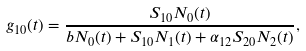<formula> <loc_0><loc_0><loc_500><loc_500>g _ { 1 0 } ( t ) = \frac { S _ { 1 0 } N _ { 0 } ( t ) } { b N _ { 0 } ( t ) + S _ { 1 0 } N _ { 1 } ( t ) + \alpha _ { 1 2 } S _ { 2 0 } N _ { 2 } ( t ) } ,</formula> 